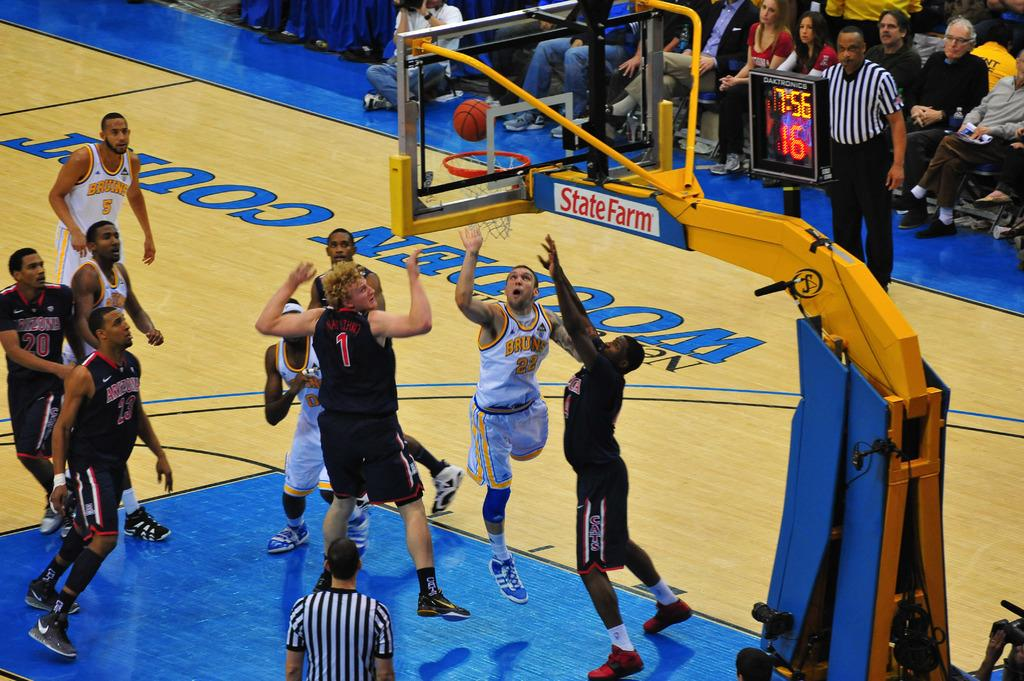<image>
Relay a brief, clear account of the picture shown. STATEFARM is advertised on the basketball net metal part during a game with one player have a #1 on his shirt. 